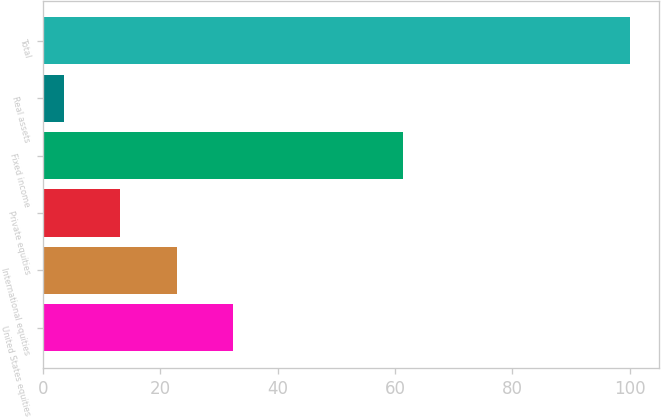<chart> <loc_0><loc_0><loc_500><loc_500><bar_chart><fcel>United States equities<fcel>International equities<fcel>Private equities<fcel>Fixed income<fcel>Real assets<fcel>Total<nl><fcel>32.45<fcel>22.8<fcel>13.15<fcel>61.3<fcel>3.5<fcel>100<nl></chart> 